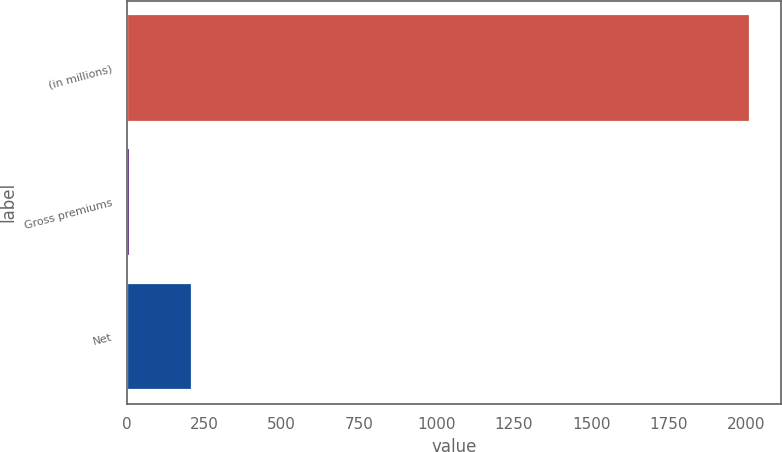<chart> <loc_0><loc_0><loc_500><loc_500><bar_chart><fcel>(in millions)<fcel>Gross premiums<fcel>Net<nl><fcel>2013<fcel>9<fcel>209.4<nl></chart> 